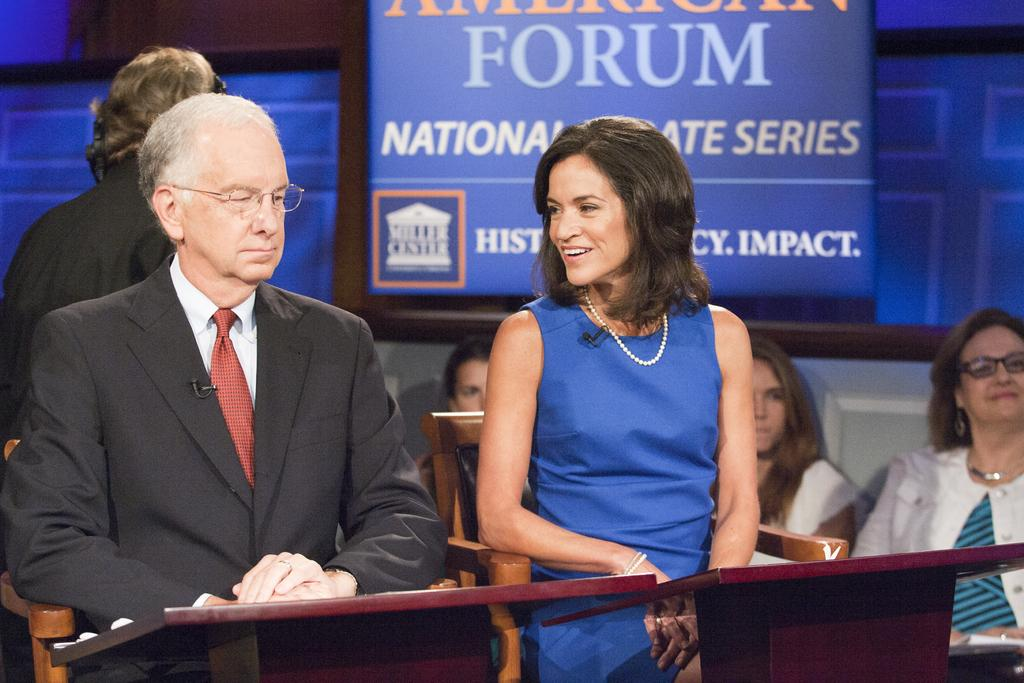How many people are sitting in the image? There are two people sitting on chairs in the image. What objects are in front of the people? There are two tables in front of the people. Can you describe the background of the image? There are people visible in the background. What is on the board in the image? There is a board with some text in the image. What title does the discovery mentioned on the board have? There is no mention of a discovery or a title on the board in the image. 